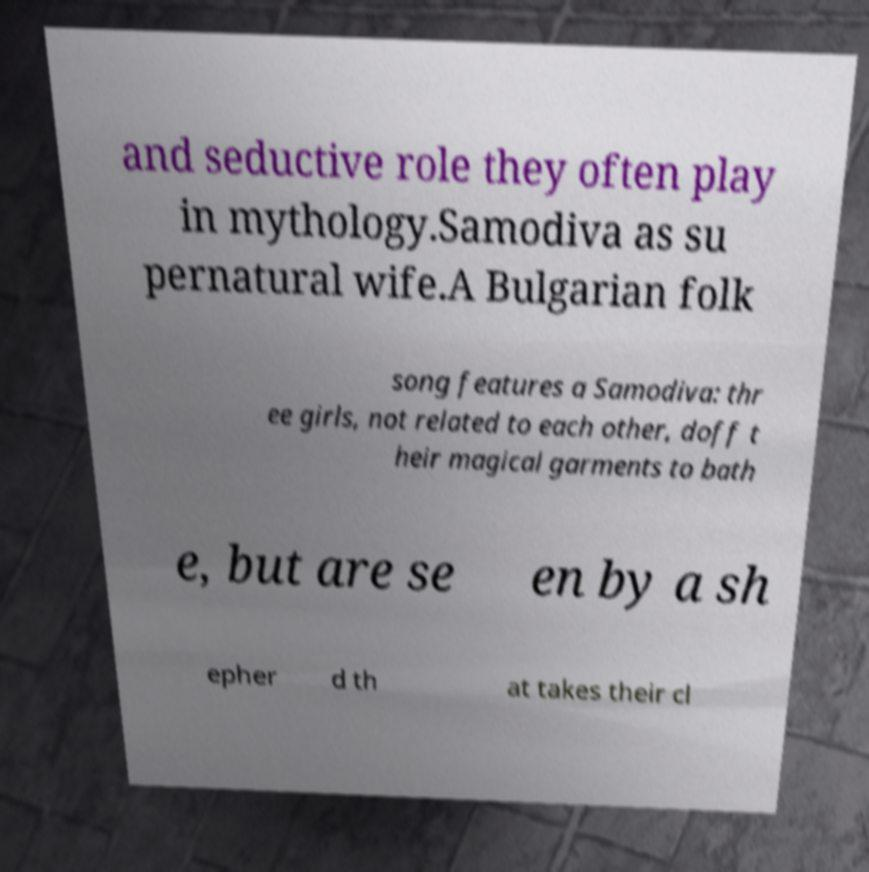Can you accurately transcribe the text from the provided image for me? and seductive role they often play in mythology.Samodiva as su pernatural wife.A Bulgarian folk song features a Samodiva: thr ee girls, not related to each other, doff t heir magical garments to bath e, but are se en by a sh epher d th at takes their cl 